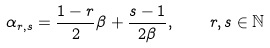<formula> <loc_0><loc_0><loc_500><loc_500>\alpha _ { r , s } = \frac { 1 - r } { 2 } \beta + \frac { s - 1 } { 2 \beta } , \quad r , s \in \mathbb { N }</formula> 